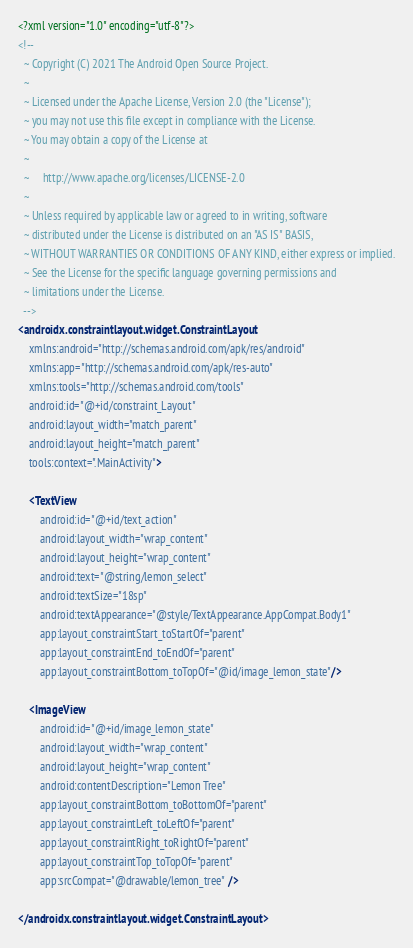Convert code to text. <code><loc_0><loc_0><loc_500><loc_500><_XML_><?xml version="1.0" encoding="utf-8"?>
<!--
  ~ Copyright (C) 2021 The Android Open Source Project.
  ~
  ~ Licensed under the Apache License, Version 2.0 (the "License");
  ~ you may not use this file except in compliance with the License.
  ~ You may obtain a copy of the License at
  ~
  ~     http://www.apache.org/licenses/LICENSE-2.0
  ~
  ~ Unless required by applicable law or agreed to in writing, software
  ~ distributed under the License is distributed on an "AS IS" BASIS,
  ~ WITHOUT WARRANTIES OR CONDITIONS OF ANY KIND, either express or implied.
  ~ See the License for the specific language governing permissions and
  ~ limitations under the License.
  -->
<androidx.constraintlayout.widget.ConstraintLayout
    xmlns:android="http://schemas.android.com/apk/res/android"
    xmlns:app="http://schemas.android.com/apk/res-auto"
    xmlns:tools="http://schemas.android.com/tools"
    android:id="@+id/constraint_Layout"
    android:layout_width="match_parent"
    android:layout_height="match_parent"
    tools:context=".MainActivity">

    <TextView
        android:id="@+id/text_action"
        android:layout_width="wrap_content"
        android:layout_height="wrap_content"
        android:text="@string/lemon_select"
        android:textSize="18sp"
        android:textAppearance="@style/TextAppearance.AppCompat.Body1"
        app:layout_constraintStart_toStartOf="parent"
        app:layout_constraintEnd_toEndOf="parent"
        app:layout_constraintBottom_toTopOf="@id/image_lemon_state"/>

    <ImageView
        android:id="@+id/image_lemon_state"
        android:layout_width="wrap_content"
        android:layout_height="wrap_content"
        android:contentDescription="Lemon Tree"
        app:layout_constraintBottom_toBottomOf="parent"
        app:layout_constraintLeft_toLeftOf="parent"
        app:layout_constraintRight_toRightOf="parent"
        app:layout_constraintTop_toTopOf="parent"
        app:srcCompat="@drawable/lemon_tree" />

</androidx.constraintlayout.widget.ConstraintLayout>
</code> 